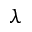Convert formula to latex. <formula><loc_0><loc_0><loc_500><loc_500>\lambda</formula> 